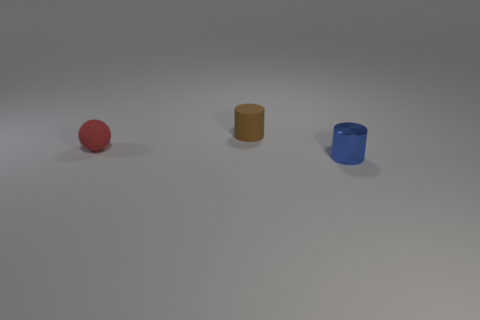Are there any other things that are made of the same material as the blue cylinder?
Provide a succinct answer. No. The blue thing has what size?
Offer a very short reply. Small. How many spheres are the same size as the blue metallic thing?
Provide a short and direct response. 1. Are there fewer tiny things on the left side of the tiny metallic object than rubber spheres behind the small red rubber thing?
Offer a terse response. No. What is the size of the thing that is behind the small rubber object in front of the cylinder behind the tiny blue shiny cylinder?
Make the answer very short. Small. There is a object that is both in front of the small matte cylinder and right of the tiny red rubber sphere; how big is it?
Your response must be concise. Small. There is a thing that is on the right side of the cylinder that is behind the small red ball; what is its shape?
Provide a succinct answer. Cylinder. Is there any other thing of the same color as the metallic cylinder?
Ensure brevity in your answer.  No. There is a matte object behind the tiny red rubber sphere; what is its shape?
Provide a succinct answer. Cylinder. What shape is the thing that is both in front of the brown rubber object and right of the rubber ball?
Keep it short and to the point. Cylinder. 